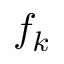<formula> <loc_0><loc_0><loc_500><loc_500>f _ { k }</formula> 